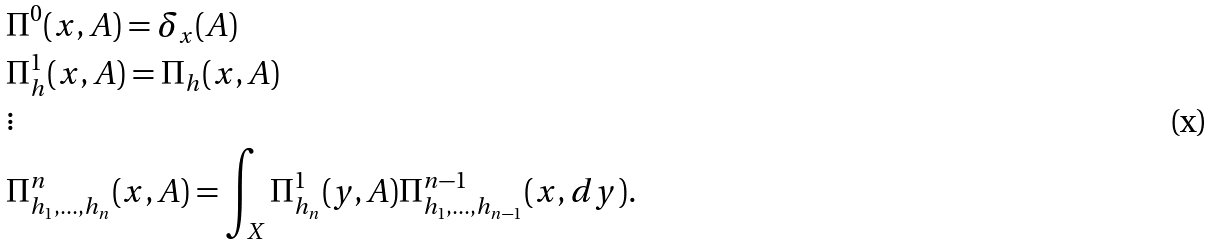<formula> <loc_0><loc_0><loc_500><loc_500>& \Pi ^ { 0 } ( x , A ) = \delta _ { x } ( A ) \\ & \Pi _ { h } ^ { 1 } ( x , A ) = \Pi _ { h } ( x , A ) \\ & \vdots \\ & \Pi _ { h _ { 1 } , \dots , h _ { n } } ^ { n } ( x , A ) = \int _ { X } \Pi _ { h _ { n } } ^ { 1 } ( y , A ) \Pi _ { h _ { 1 } , \dots , h _ { n - 1 } } ^ { n - 1 } ( x , d y ) .</formula> 